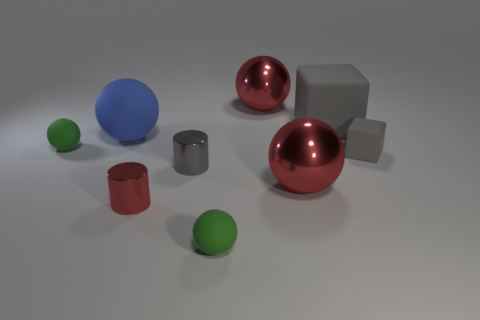Do the big matte cube and the rubber block in front of the large blue rubber thing have the same color?
Provide a succinct answer. Yes. Is the number of small green rubber things less than the number of big cyan things?
Your answer should be compact. No. There is a rubber sphere that is in front of the large blue rubber ball and behind the small gray rubber cube; what is its size?
Provide a short and direct response. Small. There is a block that is to the right of the big block; is its color the same as the large matte block?
Make the answer very short. Yes. Are there fewer small gray rubber things that are in front of the blue thing than shiny balls?
Offer a terse response. Yes. What is the shape of the tiny thing that is made of the same material as the gray cylinder?
Give a very brief answer. Cylinder. Does the gray cylinder have the same material as the small red cylinder?
Provide a succinct answer. Yes. Are there fewer large objects behind the gray metallic object than big blue balls on the right side of the large blue ball?
Offer a very short reply. No. There is a metallic cylinder that is the same color as the tiny matte block; what is its size?
Provide a short and direct response. Small. What number of matte things are behind the small rubber sphere that is behind the matte ball that is in front of the small gray metal cylinder?
Keep it short and to the point. 2. 